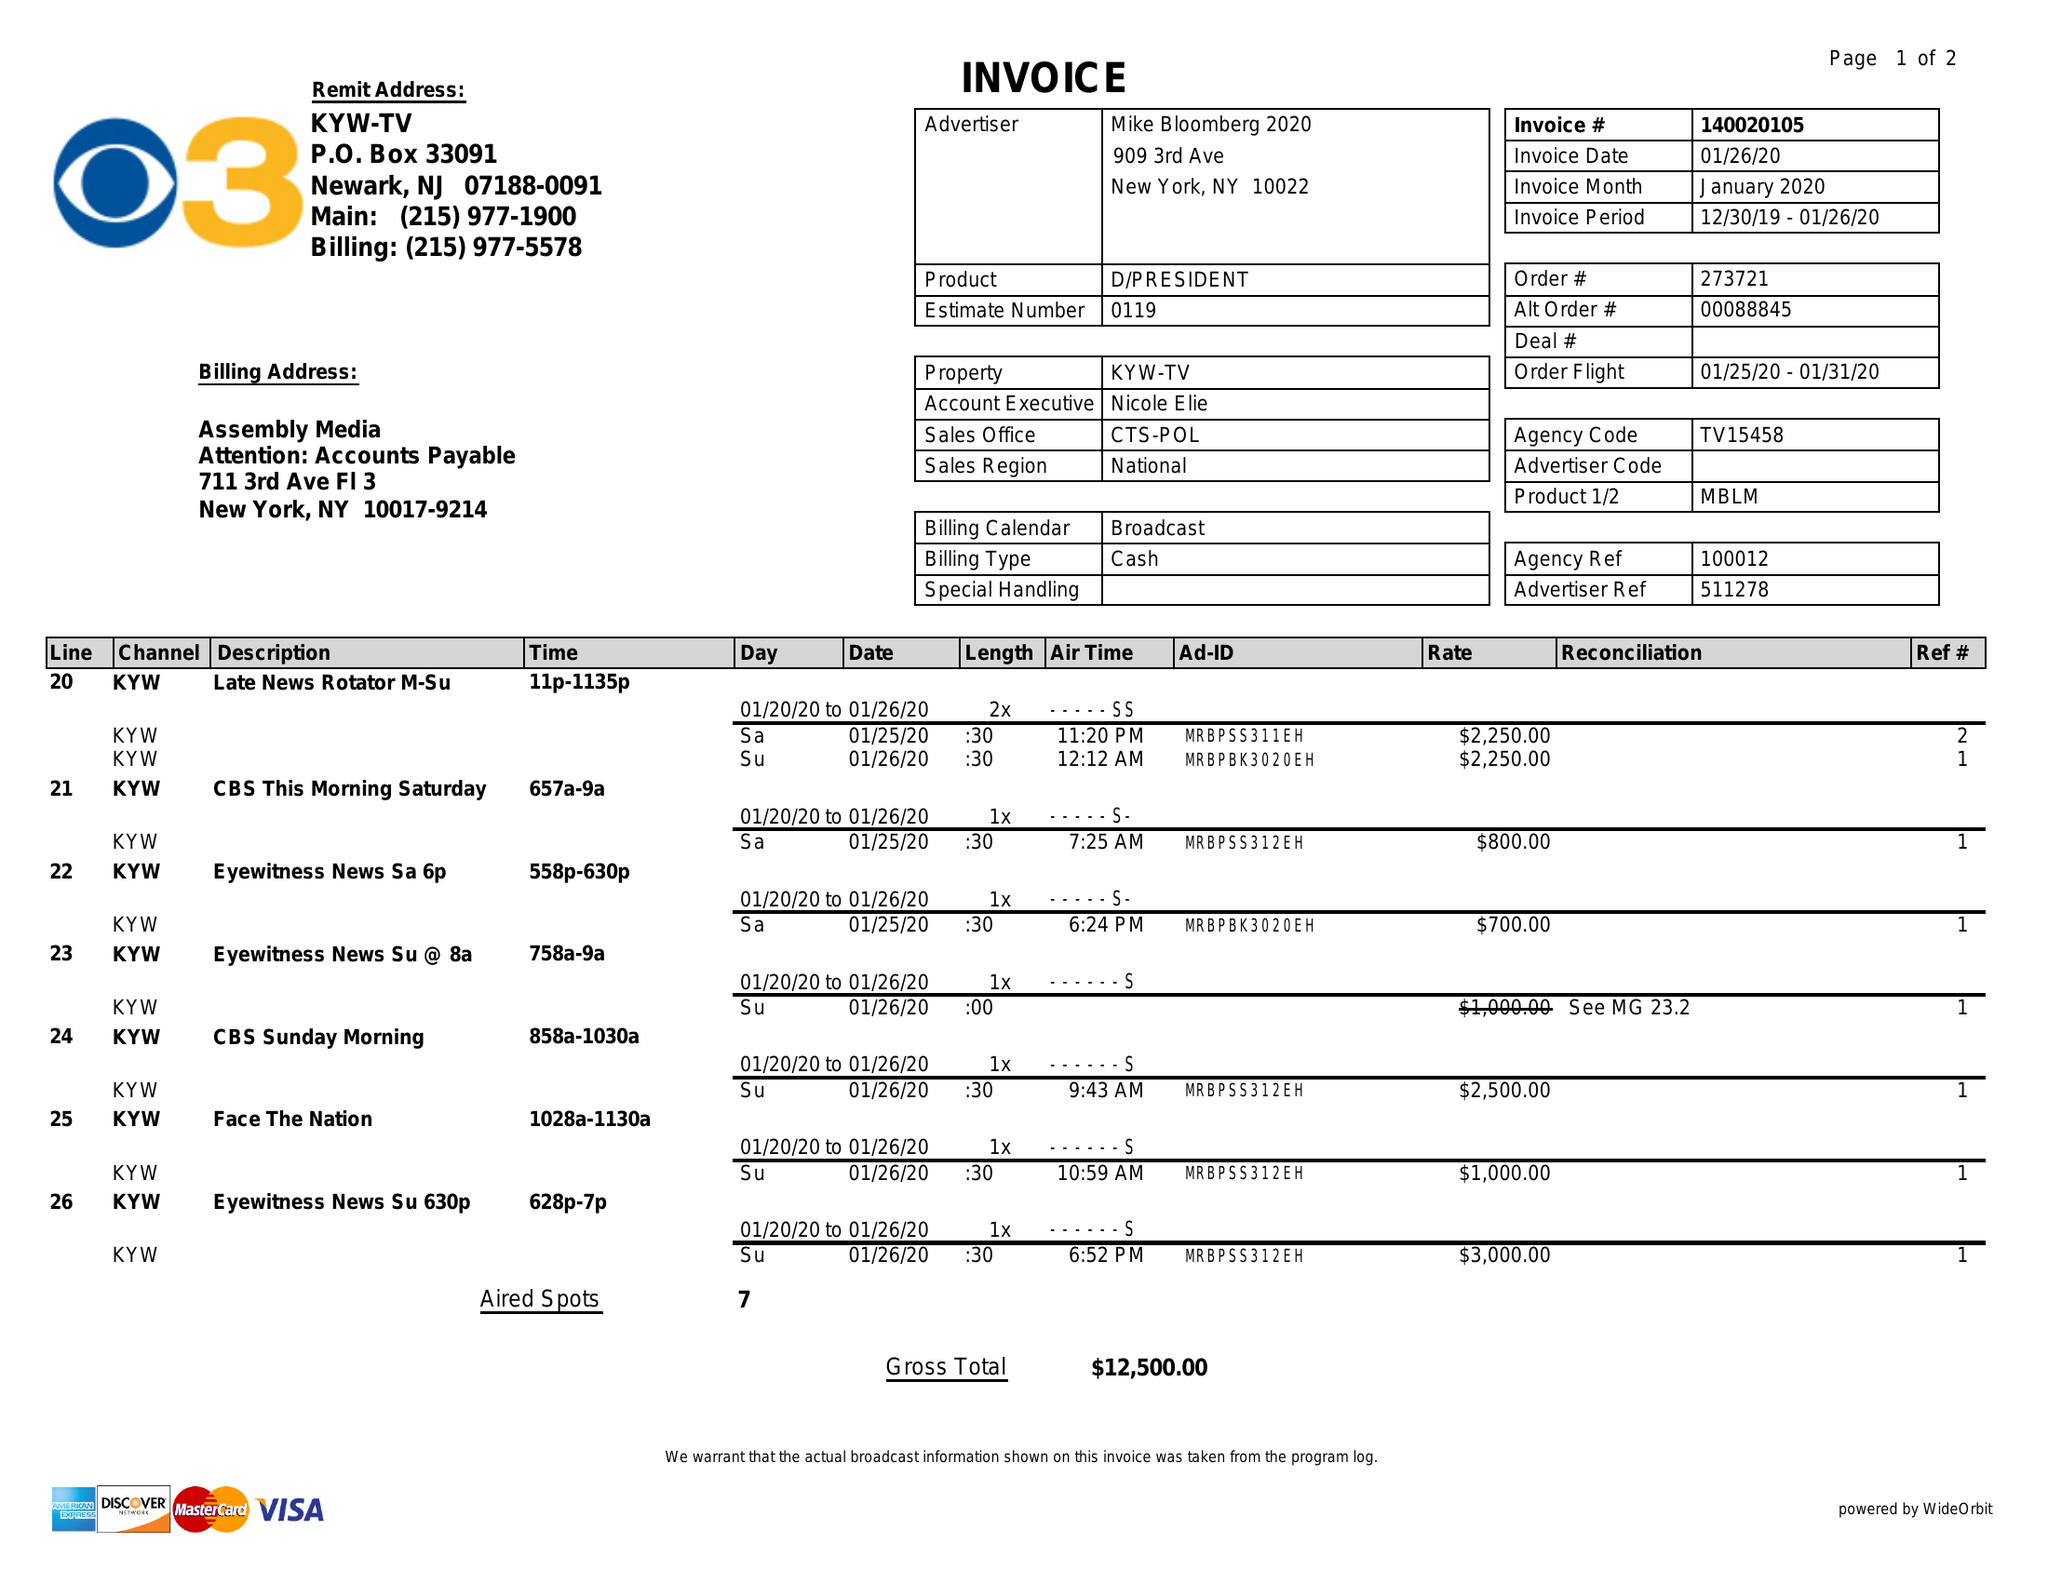What is the value for the gross_amount?
Answer the question using a single word or phrase. 12500.00 